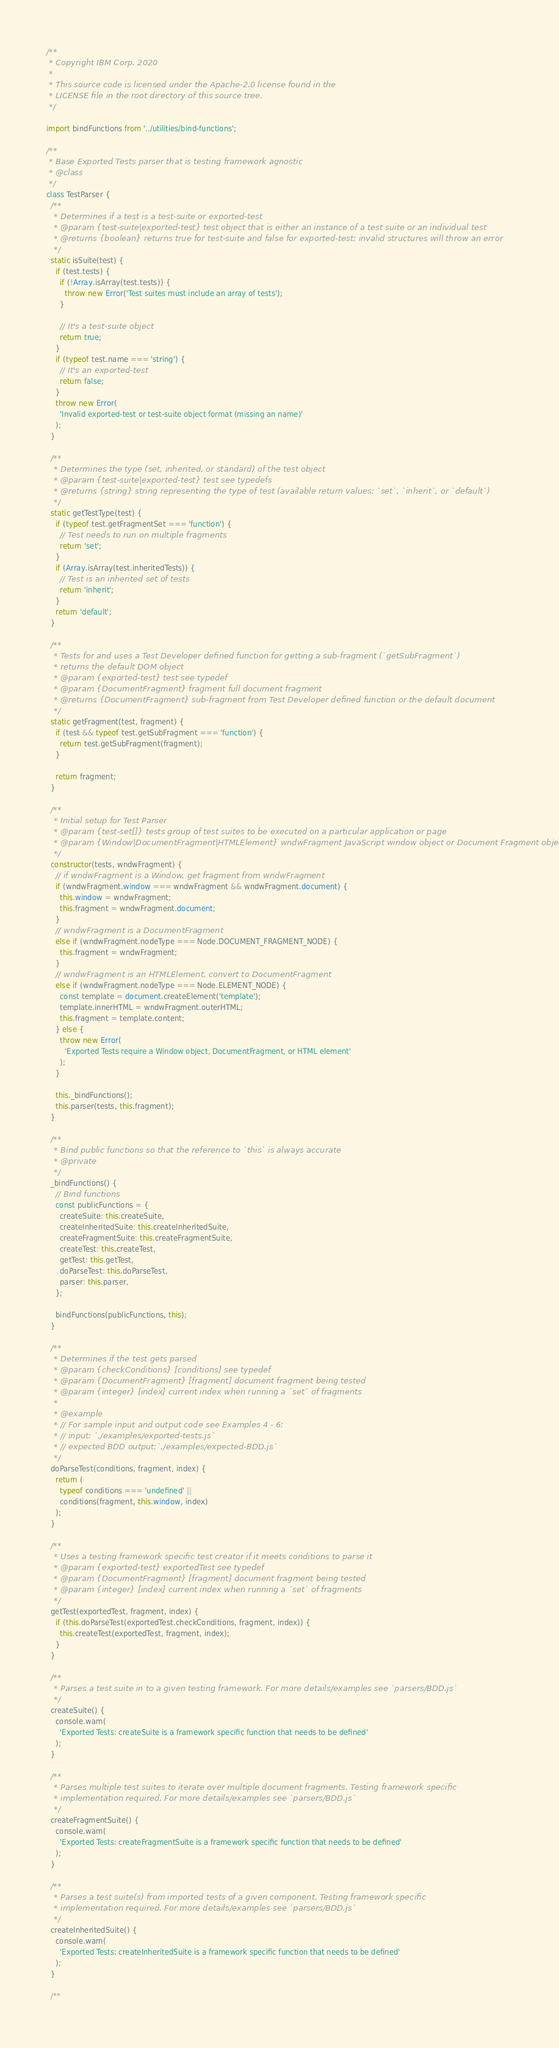Convert code to text. <code><loc_0><loc_0><loc_500><loc_500><_JavaScript_>/**
 * Copyright IBM Corp. 2020
 *
 * This source code is licensed under the Apache-2.0 license found in the
 * LICENSE file in the root directory of this source tree.
 */

import bindFunctions from '../utilities/bind-functions';

/**
 * Base Exported Tests parser that is testing framework agnostic
 * @class
 */
class TestParser {
  /**
   * Determines if a test is a test-suite or exported-test
   * @param {test-suite|exported-test} test object that is either an instance of a test suite or an individual test
   * @returns {boolean} returns true for test-suite and false for exported-test; invalid structures will throw an error
   */
  static isSuite(test) {
    if (test.tests) {
      if (!Array.isArray(test.tests)) {
        throw new Error('Test suites must include an array of tests');
      }

      // It's a test-suite object
      return true;
    }
    if (typeof test.name === 'string') {
      // It's an exported-test
      return false;
    }
    throw new Error(
      'Invalid exported-test or test-suite object format (missing an name)'
    );
  }

  /**
   * Determines the type (set, inherited, or standard) of the test object
   * @param {test-suite|exported-test} test see typedefs
   * @returns {string} string representing the type of test (available return values: `set`, `inherit`, or `default`)
   */
  static getTestType(test) {
    if (typeof test.getFragmentSet === 'function') {
      // Test needs to run on multiple fragments
      return 'set';
    }
    if (Array.isArray(test.inheritedTests)) {
      // Test is an inherited set of tests
      return 'inherit';
    }
    return 'default';
  }

  /**
   * Tests for and uses a Test Developer defined function for getting a sub-fragment (`getSubFragment`)
   * returns the default DOM object
   * @param {exported-test} test see typedef
   * @param {DocumentFragment} fragment full document fragment
   * @returns {DocumentFragment} sub-fragment from Test Developer defined function or the default document
   */
  static getFragment(test, fragment) {
    if (test && typeof test.getSubFragment === 'function') {
      return test.getSubFragment(fragment);
    }

    return fragment;
  }

  /**
   * Initial setup for Test Parser
   * @param {test-set[]} tests group of test suites to be executed on a particular application or page
   * @param {Window|DocumentFragment|HTMLElement} wndwFragment JavaScript window object or Document Fragment object
   */
  constructor(tests, wndwFragment) {
    // if wndwFragment is a Window, get fragment from wndwFragment
    if (wndwFragment.window === wndwFragment && wndwFragment.document) {
      this.window = wndwFragment;
      this.fragment = wndwFragment.document;
    }
    // wndwFragment is a DocumentFragment
    else if (wndwFragment.nodeType === Node.DOCUMENT_FRAGMENT_NODE) {
      this.fragment = wndwFragment;
    }
    // wndwFragment is an HTMLElement, convert to DocumentFragment
    else if (wndwFragment.nodeType === Node.ELEMENT_NODE) {
      const template = document.createElement('template');
      template.innerHTML = wndwFragment.outerHTML;
      this.fragment = template.content;
    } else {
      throw new Error(
        'Exported Tests require a Window object, DocumentFragment, or HTML element'
      );
    }

    this._bindFunctions();
    this.parser(tests, this.fragment);
  }

  /**
   * Bind public functions so that the reference to `this` is always accurate
   * @private
   */
  _bindFunctions() {
    // Bind functions
    const publicFunctions = {
      createSuite: this.createSuite,
      createInheritedSuite: this.createInheritedSuite,
      createFragmentSuite: this.createFragmentSuite,
      createTest: this.createTest,
      getTest: this.getTest,
      doParseTest: this.doParseTest,
      parser: this.parser,
    };

    bindFunctions(publicFunctions, this);
  }

  /**
   * Determines if the test gets parsed
   * @param {checkConditions} [conditions] see typedef
   * @param {DocumentFragment} [fragment] document fragment being tested
   * @param {integer} [index] current index when running a `set` of fragments
   *
   * @example
   * // For sample input and output code see Examples 4 - 6:
   * // input: `./examples/exported-tests.js`
   * // expected BDD output:`./examples/expected-BDD.js`
   */
  doParseTest(conditions, fragment, index) {
    return (
      typeof conditions === 'undefined' ||
      conditions(fragment, this.window, index)
    );
  }

  /**
   * Uses a testing framework specific test creator if it meets conditions to parse it
   * @param {exported-test} exportedTest see typedef
   * @param {DocumentFragment} [fragment] document fragment being tested
   * @param {integer} [index] current index when running a `set` of fragments
   */
  getTest(exportedTest, fragment, index) {
    if (this.doParseTest(exportedTest.checkConditions, fragment, index)) {
      this.createTest(exportedTest, fragment, index);
    }
  }

  /**
   * Parses a test suite in to a given testing framework. For more details/examples see `parsers/BDD.js`
   */
  createSuite() {
    console.warn(
      'Exported Tests: createSuite is a framework specific function that needs to be defined'
    );
  }

  /**
   * Parses multiple test suites to iterate over multiple document fragments. Testing framework specific
   * implementation required. For more details/examples see `parsers/BDD.js`
   */
  createFragmentSuite() {
    console.warn(
      'Exported Tests: createFragmentSuite is a framework specific function that needs to be defined'
    );
  }

  /**
   * Parses a test suite(s) from imported tests of a given component. Testing framework specific
   * implementation required. For more details/examples see `parsers/BDD.js`
   */
  createInheritedSuite() {
    console.warn(
      'Exported Tests: createInheritedSuite is a framework specific function that needs to be defined'
    );
  }

  /**</code> 